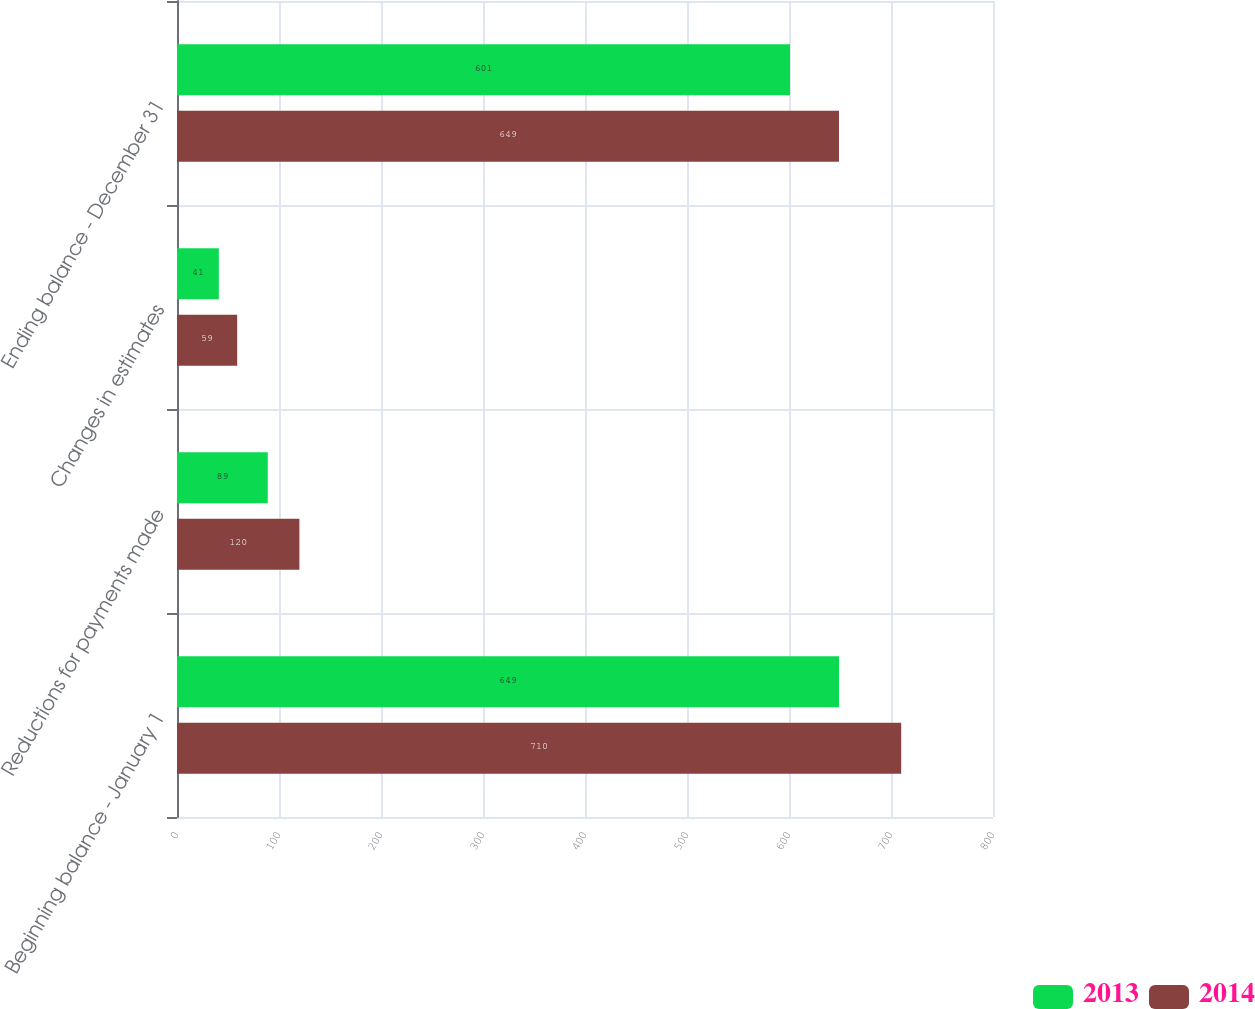<chart> <loc_0><loc_0><loc_500><loc_500><stacked_bar_chart><ecel><fcel>Beginning balance - January 1<fcel>Reductions for payments made<fcel>Changes in estimates<fcel>Ending balance - December 31<nl><fcel>2013<fcel>649<fcel>89<fcel>41<fcel>601<nl><fcel>2014<fcel>710<fcel>120<fcel>59<fcel>649<nl></chart> 